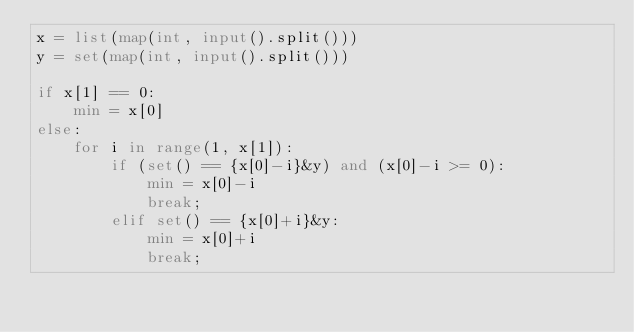Convert code to text. <code><loc_0><loc_0><loc_500><loc_500><_Python_>x = list(map(int, input().split()))
y = set(map(int, input().split()))

if x[1] == 0:
    min = x[0]
else:
    for i in range(1, x[1]):
        if (set() == {x[0]-i}&y) and (x[0]-i >= 0):
            min = x[0]-i
            break;
        elif set() == {x[0]+i}&y:
            min = x[0]+i
            break;
</code> 